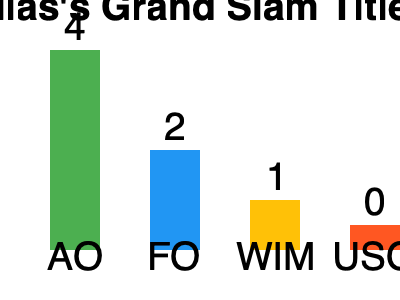Based on the bar chart showing Guillermo Vilas's Grand Slam titles, what was the total number of Grand Slam singles titles he won in his career? To determine the total number of Grand Slam singles titles won by Guillermo Vilas, we need to sum up the titles from each tournament:

1. Australian Open (AO): 4 titles
2. French Open (FO): 2 titles
3. Wimbledon (WIM): 1 title
4. US Open (USO): 0 titles

Calculating the total:
$$ 4 + 2 + 1 + 0 = 7 $$

Therefore, Guillermo Vilas won a total of 7 Grand Slam singles titles in his career.
Answer: 7 